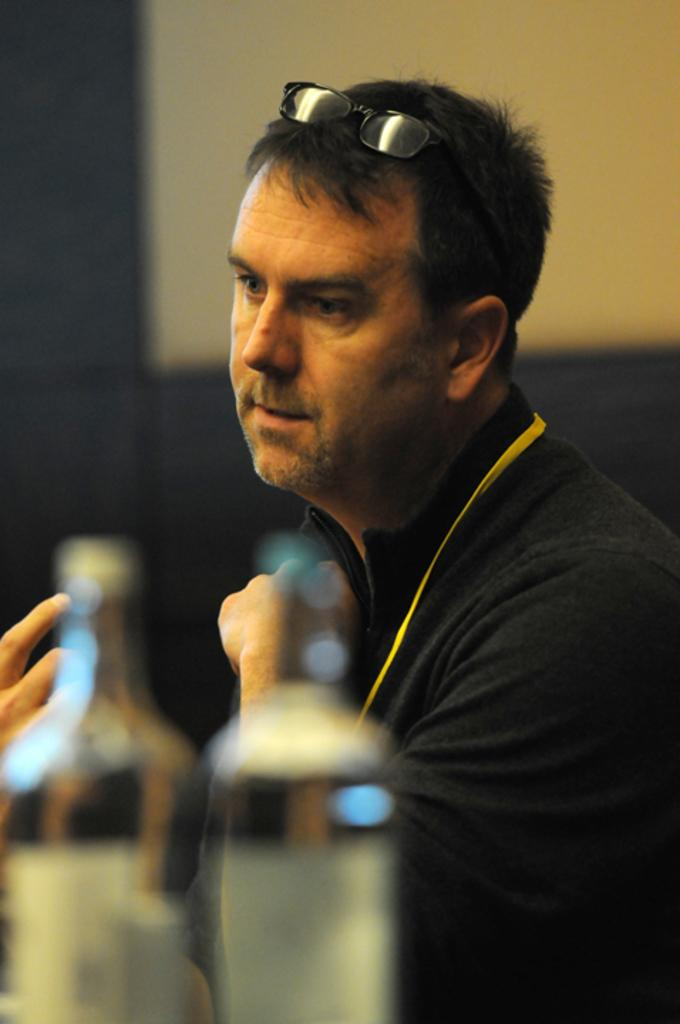What can be seen in the image? There is a person in the image. Can you describe the person's appearance? The person is wearing glasses (specs). What else is present in the image? There are bottles in the image. How are the bottles depicted? The bottles appear blurred. What is the condition of the background in the image? The background of the image is blurred. What month is it in the image? The month cannot be determined from the image, as it does not contain any information about the time of year. Can you tell me how many floors are visible in the image? There is no reference to floors in the image, as it features a person, bottles, and a blurred background. 